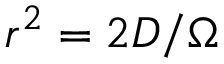Convert formula to latex. <formula><loc_0><loc_0><loc_500><loc_500>r ^ { 2 } = 2 D / \Omega</formula> 